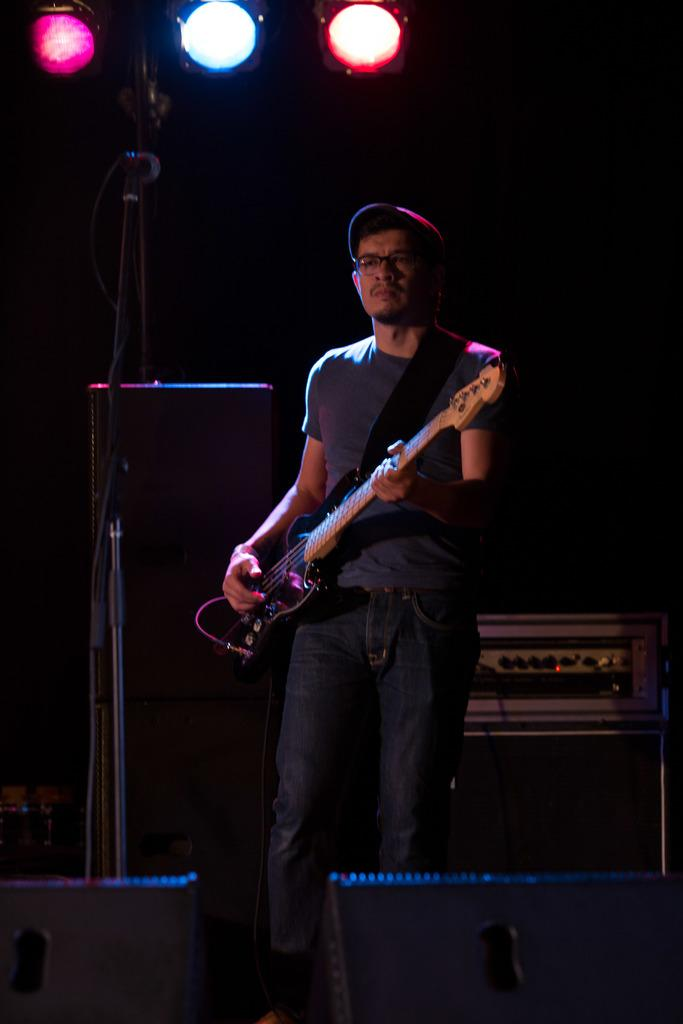What is the main subject of the image? There is a man in the image. What is the man doing in the image? The man is standing in the image. What object is the man holding in the image? The man is holding a guitar in his hand. Is the man sleeping in the image? No, the man is not sleeping in the image; he is standing and holding a guitar. Can the man fly in the image? No, the man cannot fly in the image; he is standing on the ground. 